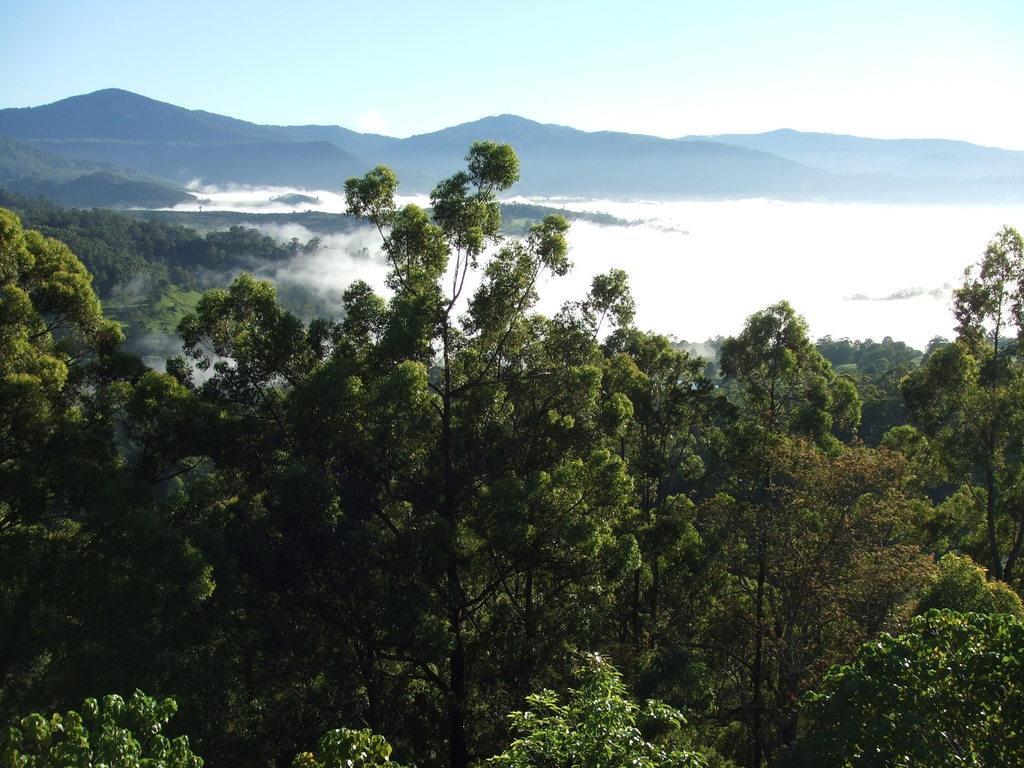How would you summarize this image in a sentence or two? In this image we can see sky with clouds, hills, fog and trees. 